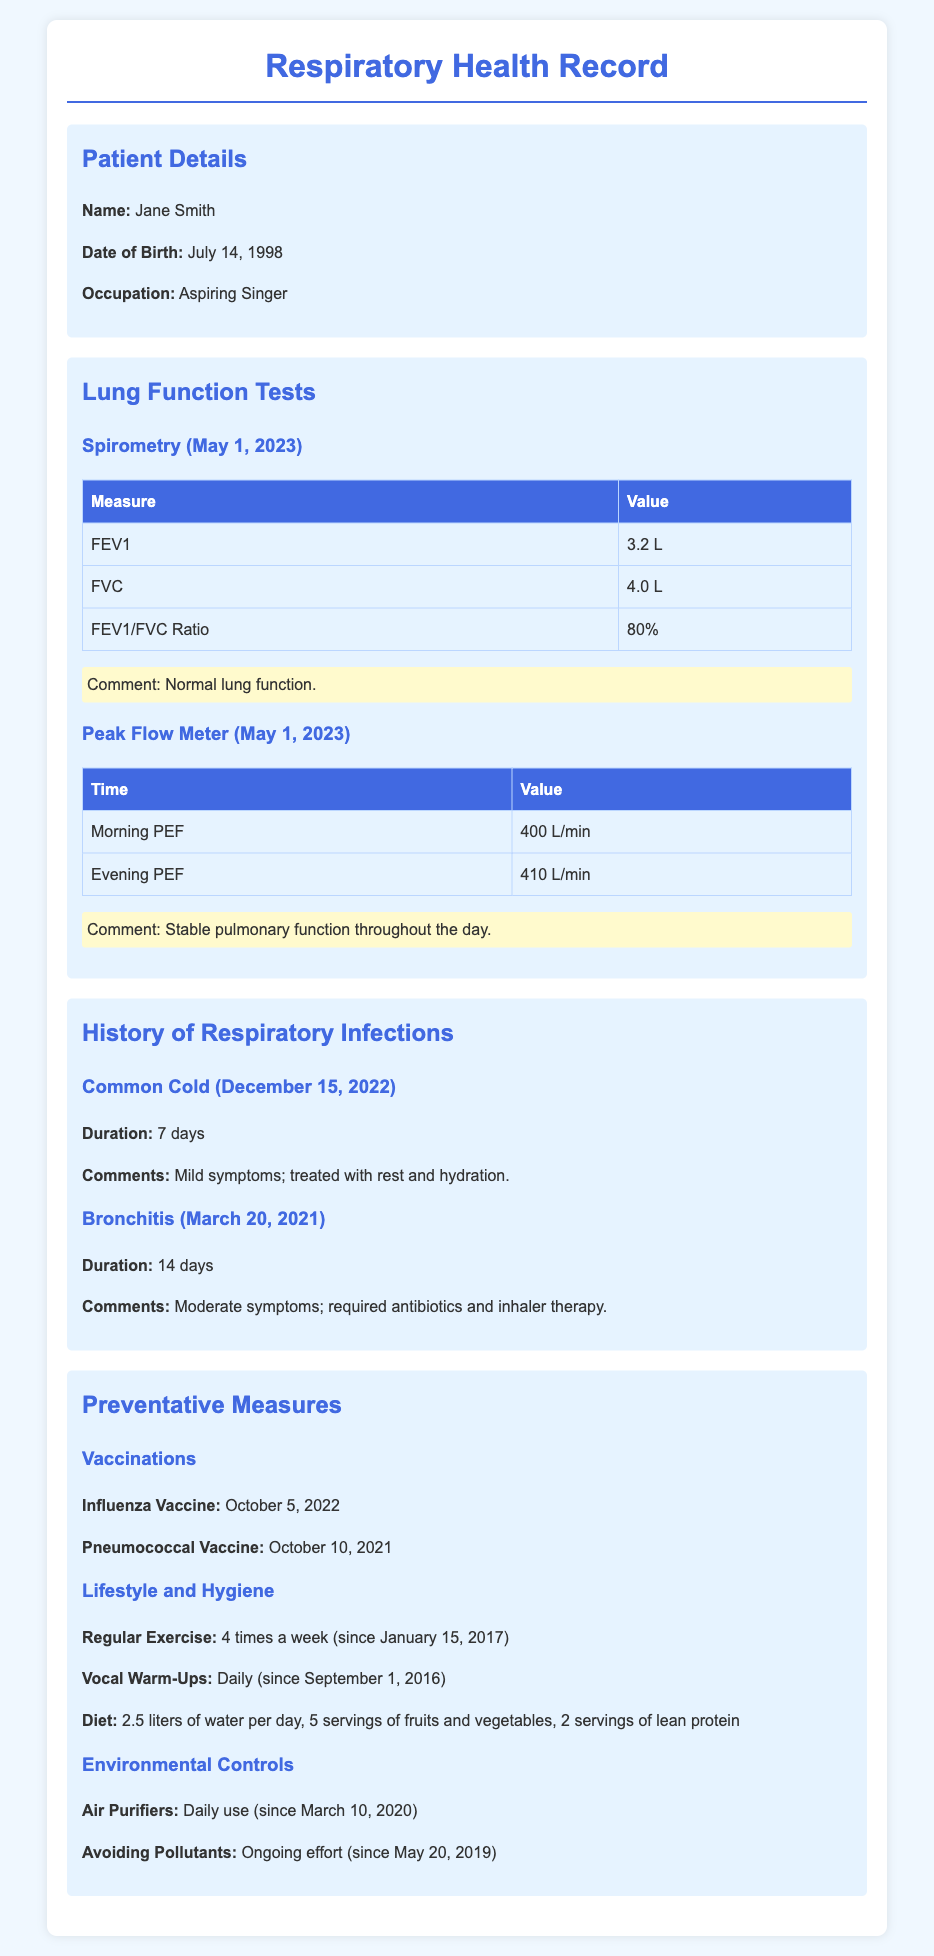What is the patient's name? The patient's name is listed at the top of the document.
Answer: Jane Smith What is the FEV1 value from the lung function tests? The FEV1 value is provided in the Spirometry section under Lung Function Tests.
Answer: 3.2 L What was the duration of the bronchitis episode? The duration of bronchitis can be found in the History of Respiratory Infections section.
Answer: 14 days When was the influenza vaccine administered? The date of the influenza vaccine is specified in the Preventative Measures section.
Answer: October 5, 2022 How often does the patient exercise? The frequency of exercise is provided under Lifestyle and Hygiene in the Preventative Measures section.
Answer: 4 times a week What is the overall comment for the spirometry results? The comment can be found below the spirometry measures, summarizing the lung function results.
Answer: Normal lung function What is the patient's occupation? The occupation is specified in the Patient Details section of the document.
Answer: Aspiring Singer How many liters of water does the patient consume daily? The daily water intake is mentioned under Diet in the Preventative Measures section.
Answer: 2.5 liters What type of therapy was required for bronchitis? This information is found in the comments for the bronchitis episode in the History of Respiratory Infections section.
Answer: Antibiotics and inhaler therapy 